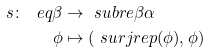Convert formula to latex. <formula><loc_0><loc_0><loc_500><loc_500>s \colon \ e q { \beta } & \to \ s u b r e { \beta } { \alpha } \\ \phi & \mapsto ( \ s u r j r e p ( \phi ) , \phi )</formula> 